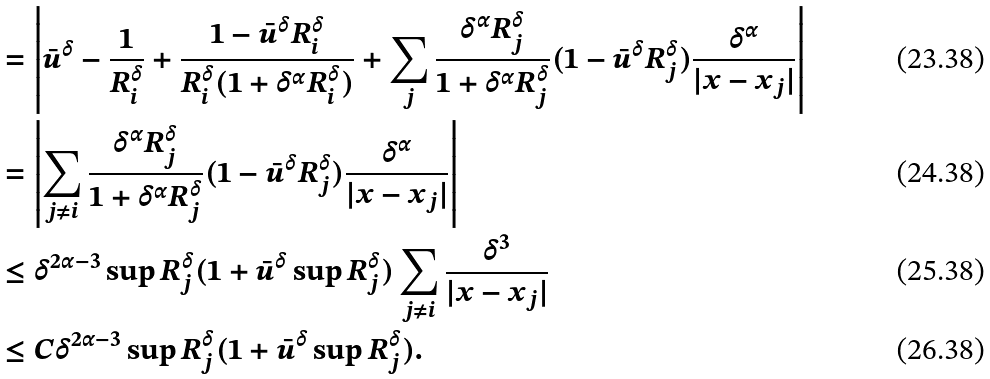<formula> <loc_0><loc_0><loc_500><loc_500>& = \left | \bar { u } ^ { \delta } - \frac { 1 } { R _ { i } ^ { \delta } } + \frac { 1 - \bar { u } ^ { \delta } R _ { i } ^ { \delta } } { R _ { i } ^ { \delta } ( 1 + \delta ^ { \alpha } R _ { i } ^ { \delta } ) } + \sum _ { j } \frac { \delta ^ { \alpha } R _ { j } ^ { \delta } } { 1 + \delta ^ { \alpha } R _ { j } ^ { \delta } } ( 1 - \bar { u } ^ { \delta } R _ { j } ^ { \delta } ) \frac { \delta ^ { \alpha } } { | x - x _ { j } | } \right | \\ & = \left | \sum _ { j \neq i } \frac { \delta ^ { \alpha } R _ { j } ^ { \delta } } { 1 + \delta ^ { \alpha } R _ { j } ^ { \delta } } ( 1 - \bar { u } ^ { \delta } R _ { j } ^ { \delta } ) \frac { \delta ^ { \alpha } } { | x - x _ { j } | } \right | \\ & \leq \delta ^ { 2 \alpha - 3 } \sup R _ { j } ^ { \delta } ( 1 + \bar { u } ^ { \delta } \sup R _ { j } ^ { \delta } ) \sum _ { j \neq i } \frac { \delta ^ { 3 } } { | x - x _ { j } | } \\ & \leq C \delta ^ { 2 \alpha - 3 } \sup R _ { j } ^ { \delta } ( 1 + \bar { u } ^ { \delta } \sup R _ { j } ^ { \delta } ) .</formula> 